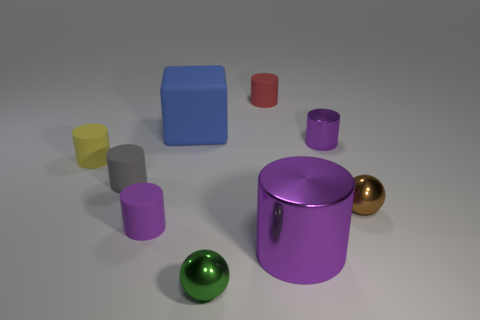Subtract all purple cylinders. How many were subtracted if there are1purple cylinders left? 2 Subtract all large cylinders. How many cylinders are left? 5 Subtract all cubes. How many objects are left? 8 Subtract all green spheres. How many spheres are left? 1 Subtract 1 spheres. How many spheres are left? 1 Subtract 0 green cylinders. How many objects are left? 9 Subtract all purple cylinders. Subtract all brown cubes. How many cylinders are left? 3 Subtract all cyan blocks. How many green spheres are left? 1 Subtract all tiny spheres. Subtract all large blue cubes. How many objects are left? 6 Add 3 big purple things. How many big purple things are left? 4 